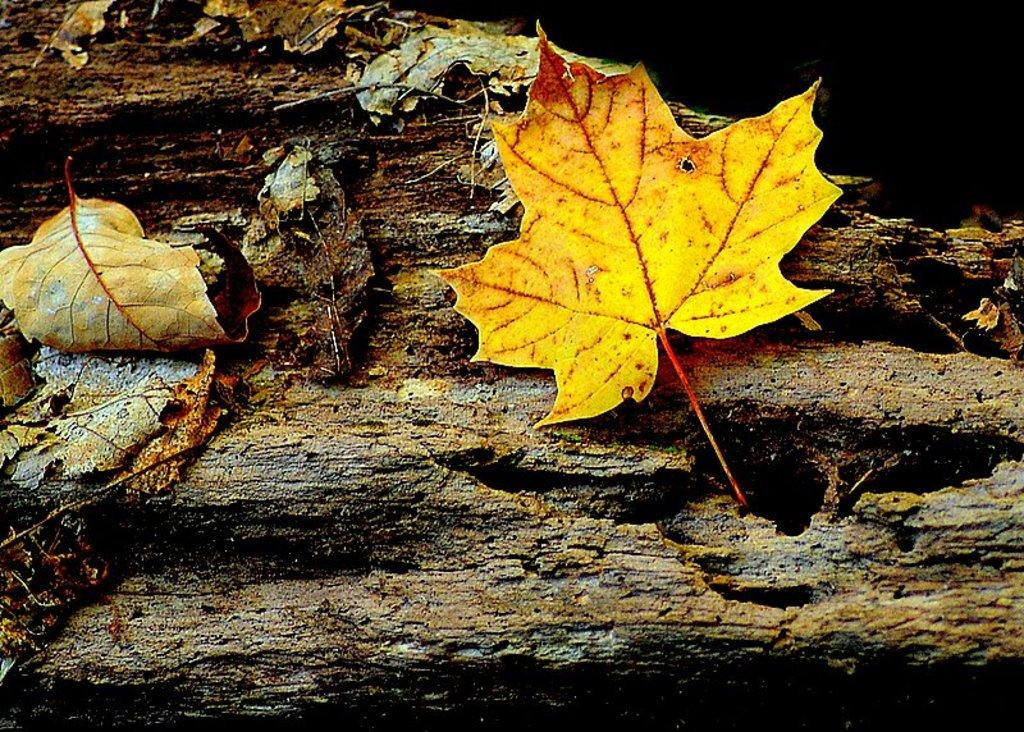What type of natural material is present in the image? There are dry leaves in the image. What surface are the dry leaves resting on? The dry leaves are on wood. What type of agreement is being signed in the image? There is no agreement or signing activity present in the image; it only features dry leaves on wood. 